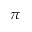Convert formula to latex. <formula><loc_0><loc_0><loc_500><loc_500>\pi</formula> 